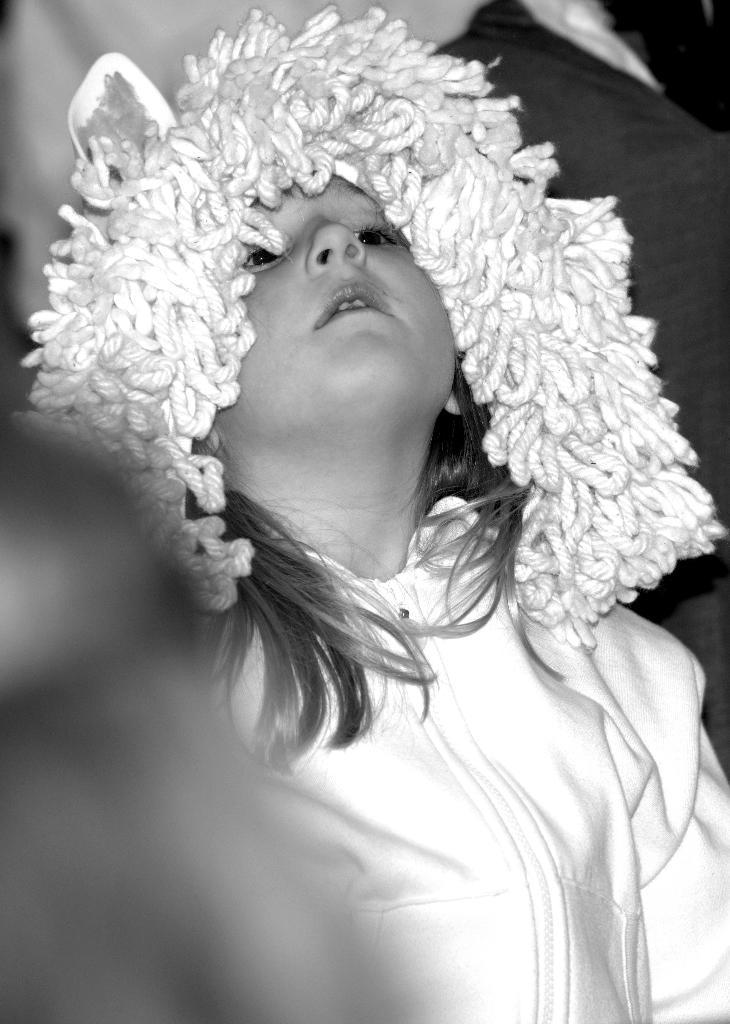Who is the main subject in the image? There is a girl in the image. What is the girl wearing? The girl is wearing a white jacket. Does the girl have a fang in the image? There is no indication of a fang in the image; the girl is simply wearing a white jacket. Is the girl serving someone in the image? There is no indication of the girl serving anyone in the image; she is just standing there wearing a white jacket. 